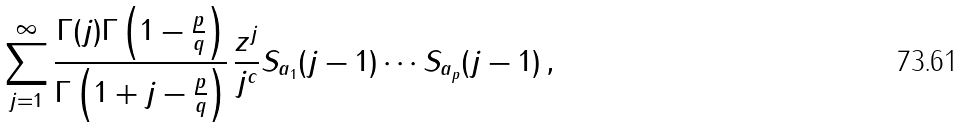<formula> <loc_0><loc_0><loc_500><loc_500>\sum _ { j = 1 } ^ { \infty } \frac { \Gamma ( j ) \Gamma \left ( 1 - \frac { p } { q } \right ) } { \Gamma \left ( 1 + j - \frac { p } { q } \right ) } \, \frac { z ^ { j } } { j ^ { c } } S _ { a _ { 1 } } ( j - 1 ) \cdots S _ { a _ { p } } ( j - 1 ) \, ,</formula> 